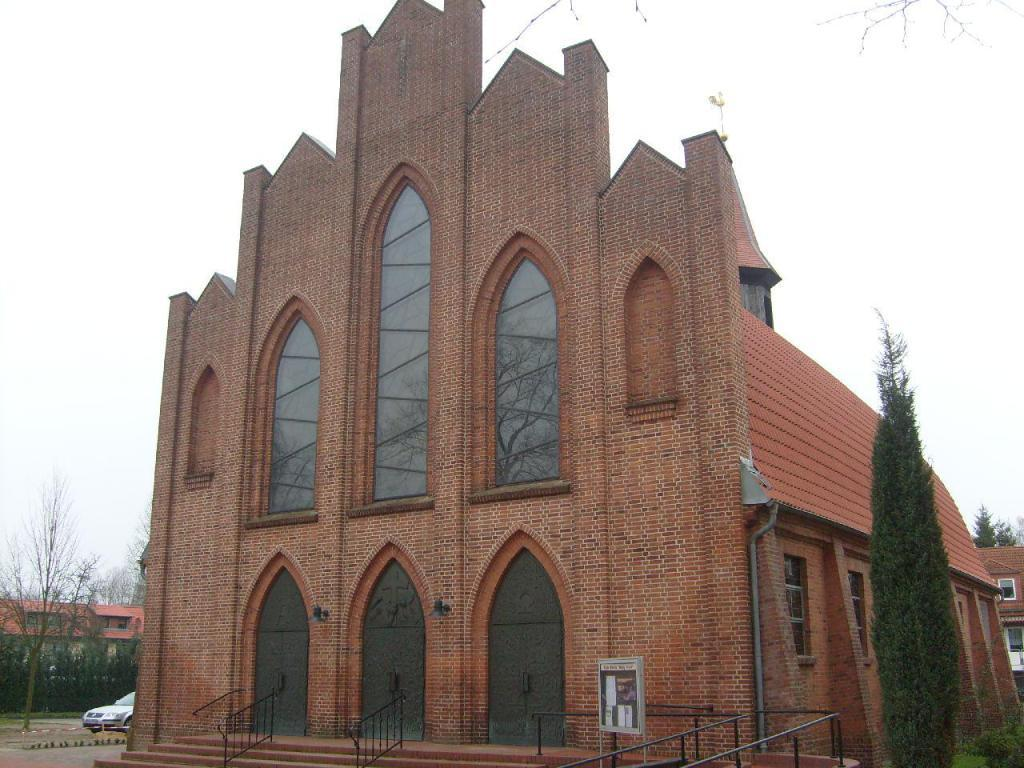What type of structure is present in the image? There is a building in the image. What can be seen in the background of the image? The sky is visible in the background of the image. What type of vegetation is present in the image? There are trees visible in the image. What type of polish is being applied to the building in the image? There is no indication in the image that any polish is being applied to the building. 